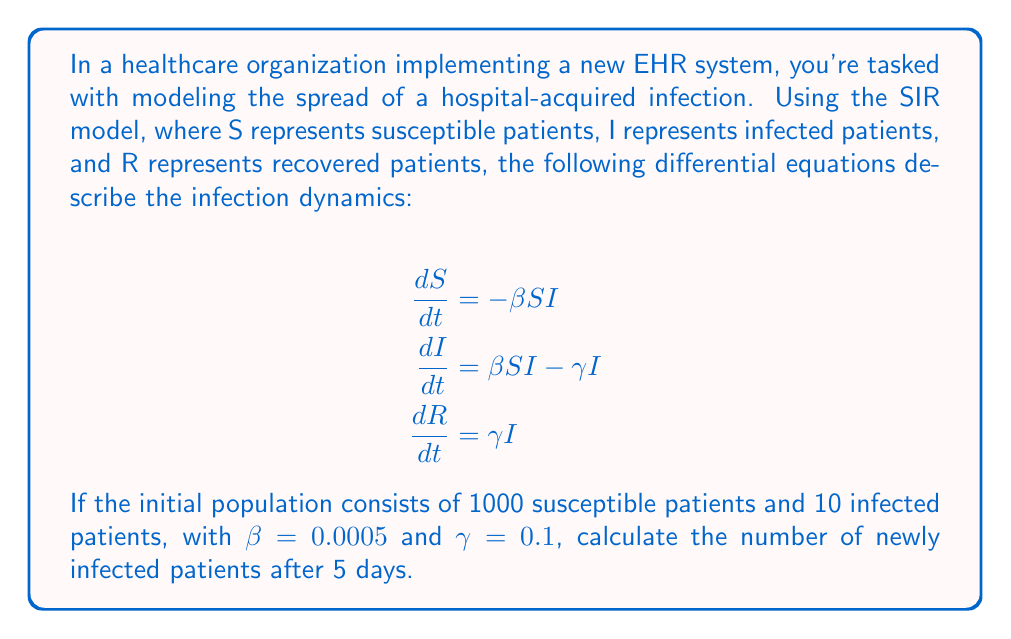Show me your answer to this math problem. To solve this problem, we need to use numerical methods to approximate the solution of the differential equations. We'll use the Euler method with a small time step to estimate the number of infected patients after 5 days.

1. Set up initial conditions:
   $S_0 = 1000$, $I_0 = 10$, $R_0 = 0$
   $\beta = 0.0005$, $\gamma = 0.1$
   Time step $\Delta t = 0.1$ days (we'll use 50 steps to cover 5 days)

2. Apply the Euler method iteratively:
   For each step $i$ from 1 to 50:
   $$\begin{align}
   S_{i+1} &= S_i + \Delta t \cdot (-\beta S_i I_i) \\
   I_{i+1} &= I_i + \Delta t \cdot (\beta S_i I_i - \gamma I_i) \\
   R_{i+1} &= R_i + \Delta t \cdot (\gamma I_i)
   \end{align}$$

3. Implement the iteration (showing first few steps):
   Step 1: 
   $S_1 = 1000 + 0.1 \cdot (-0.0005 \cdot 1000 \cdot 10) = 999.5$
   $I_1 = 10 + 0.1 \cdot (0.0005 \cdot 1000 \cdot 10 - 0.1 \cdot 10) = 10.4$
   $R_1 = 0 + 0.1 \cdot (0.1 \cdot 10) = 0.1$

   Step 2:
   $S_2 = 999.5 + 0.1 \cdot (-0.0005 \cdot 999.5 \cdot 10.4) = 998.98$
   $I_2 = 10.4 + 0.1 \cdot (0.0005 \cdot 999.5 \cdot 10.4 - 0.1 \cdot 10.4) = 10.82$
   $R_2 = 0.1 + 0.1 \cdot (0.1 \cdot 10.4) = 0.204$

   ...continue for 50 steps...

4. After 50 steps (5 days), we get:
   $S_{50} \approx 957.82$
   $I_{50} \approx 38.91$
   $R_{50} \approx 3.27$

5. Calculate the number of newly infected patients:
   Newly infected = Initial susceptible - Final susceptible
   $= 1000 - 957.82 = 42.18$
Answer: Approximately 42 patients (rounded to the nearest whole number) would be newly infected after 5 days. 